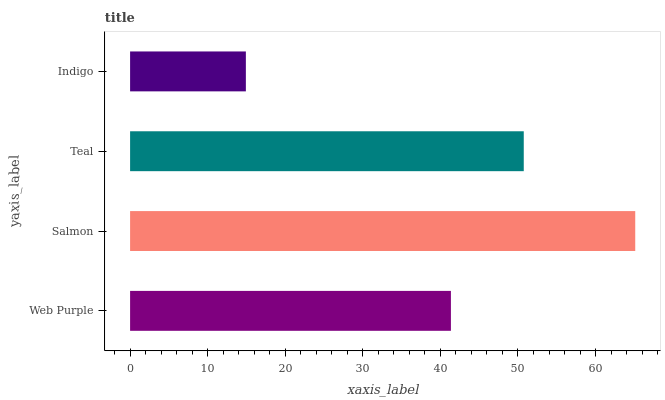Is Indigo the minimum?
Answer yes or no. Yes. Is Salmon the maximum?
Answer yes or no. Yes. Is Teal the minimum?
Answer yes or no. No. Is Teal the maximum?
Answer yes or no. No. Is Salmon greater than Teal?
Answer yes or no. Yes. Is Teal less than Salmon?
Answer yes or no. Yes. Is Teal greater than Salmon?
Answer yes or no. No. Is Salmon less than Teal?
Answer yes or no. No. Is Teal the high median?
Answer yes or no. Yes. Is Web Purple the low median?
Answer yes or no. Yes. Is Salmon the high median?
Answer yes or no. No. Is Salmon the low median?
Answer yes or no. No. 